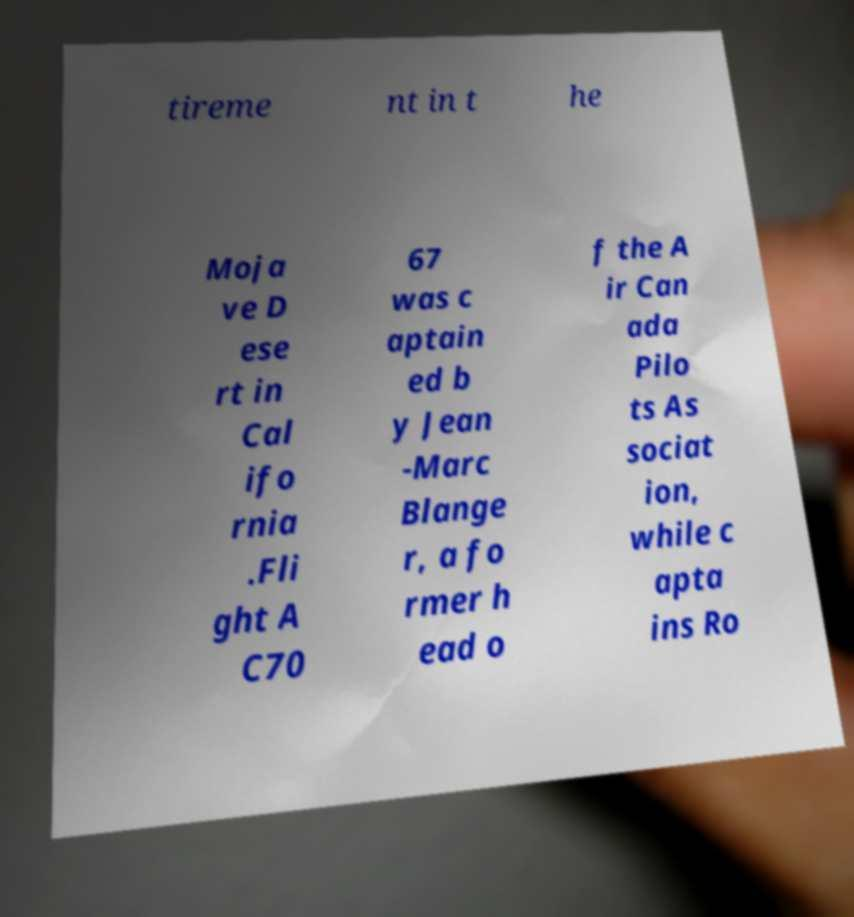There's text embedded in this image that I need extracted. Can you transcribe it verbatim? tireme nt in t he Moja ve D ese rt in Cal ifo rnia .Fli ght A C70 67 was c aptain ed b y Jean -Marc Blange r, a fo rmer h ead o f the A ir Can ada Pilo ts As sociat ion, while c apta ins Ro 